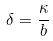Convert formula to latex. <formula><loc_0><loc_0><loc_500><loc_500>\delta = \frac { \kappa } { b }</formula> 